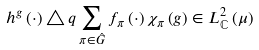<formula> <loc_0><loc_0><loc_500><loc_500>h ^ { g } \left ( \cdot \right ) \triangle q \sum _ { \pi \in \hat { G } } f _ { \pi } \left ( \cdot \right ) \chi _ { \pi } \left ( g \right ) \in L _ { \mathbb { C } } ^ { 2 } \left ( \mu \right )</formula> 